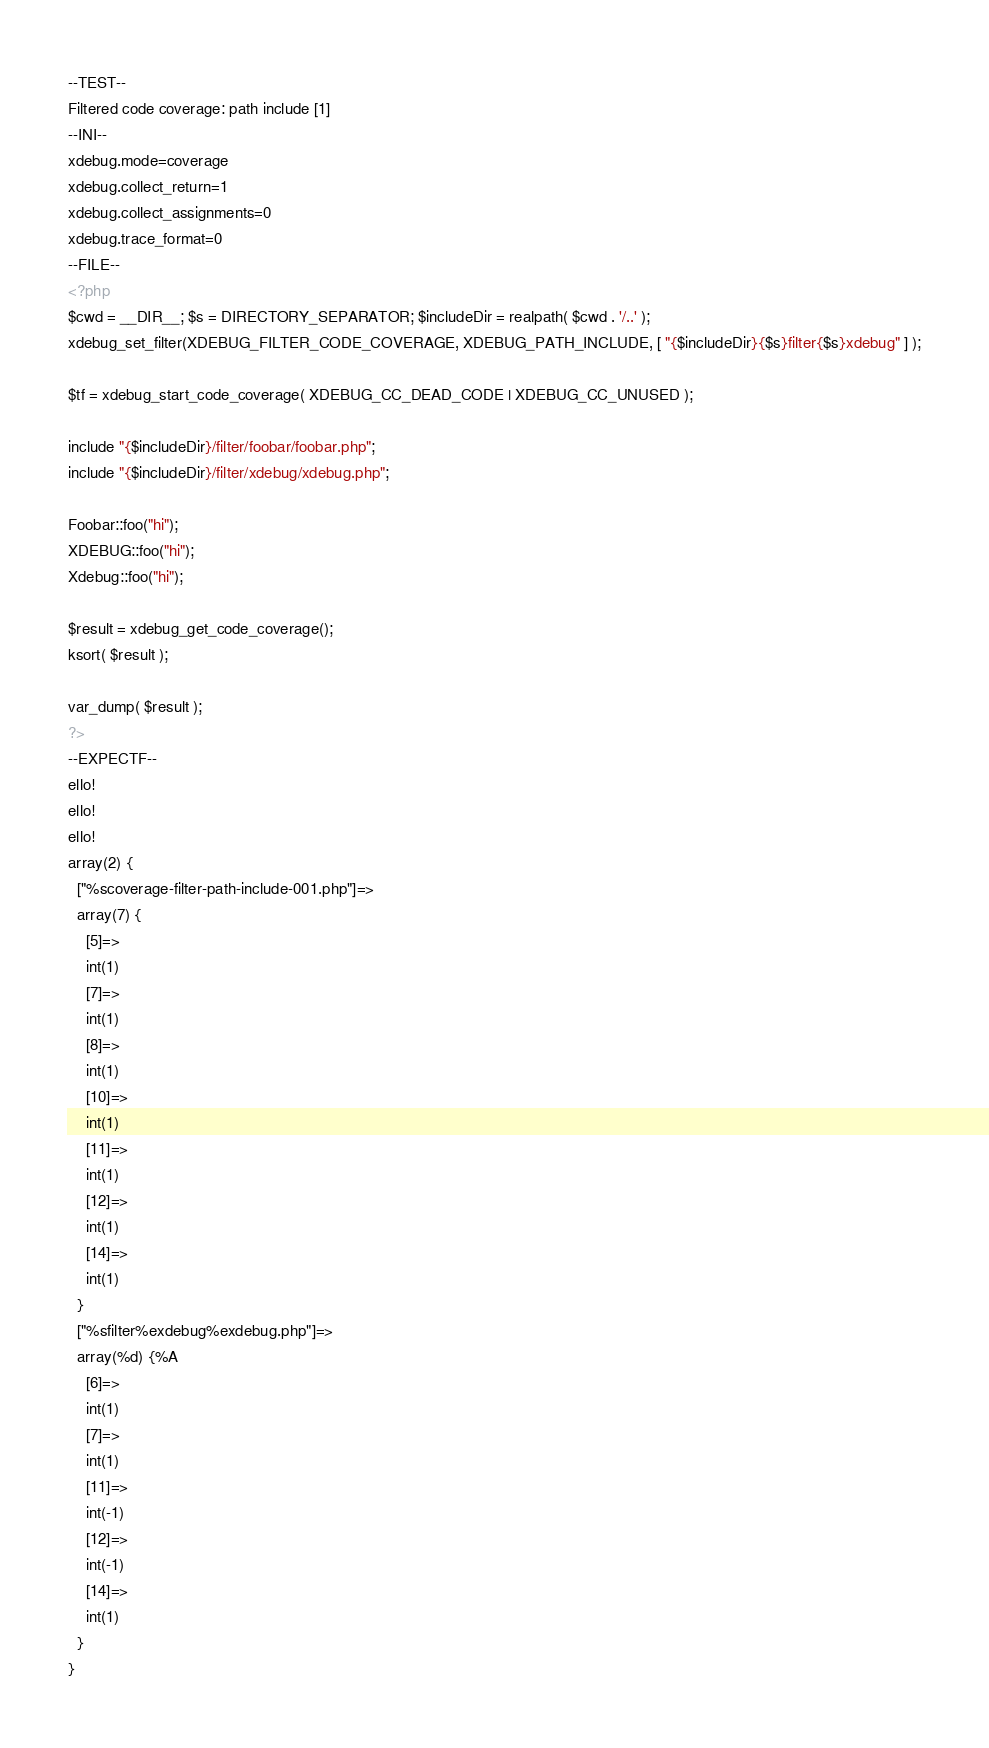Convert code to text. <code><loc_0><loc_0><loc_500><loc_500><_PHP_>--TEST--
Filtered code coverage: path include [1]
--INI--
xdebug.mode=coverage
xdebug.collect_return=1
xdebug.collect_assignments=0
xdebug.trace_format=0
--FILE--
<?php
$cwd = __DIR__; $s = DIRECTORY_SEPARATOR; $includeDir = realpath( $cwd . '/..' );
xdebug_set_filter(XDEBUG_FILTER_CODE_COVERAGE, XDEBUG_PATH_INCLUDE, [ "{$includeDir}{$s}filter{$s}xdebug" ] );

$tf = xdebug_start_code_coverage( XDEBUG_CC_DEAD_CODE | XDEBUG_CC_UNUSED );

include "{$includeDir}/filter/foobar/foobar.php";
include "{$includeDir}/filter/xdebug/xdebug.php";

Foobar::foo("hi");
XDEBUG::foo("hi");
Xdebug::foo("hi");
	
$result = xdebug_get_code_coverage();
ksort( $result );

var_dump( $result );
?>
--EXPECTF--
ello!
ello!
ello!
array(2) {
  ["%scoverage-filter-path-include-001.php"]=>
  array(7) {
    [5]=>
    int(1)
    [7]=>
    int(1)
    [8]=>
    int(1)
    [10]=>
    int(1)
    [11]=>
    int(1)
    [12]=>
    int(1)
    [14]=>
    int(1)
  }
  ["%sfilter%exdebug%exdebug.php"]=>
  array(%d) {%A
    [6]=>
    int(1)
    [7]=>
    int(1)
    [11]=>
    int(-1)
    [12]=>
    int(-1)
    [14]=>
    int(1)
  }
}
</code> 